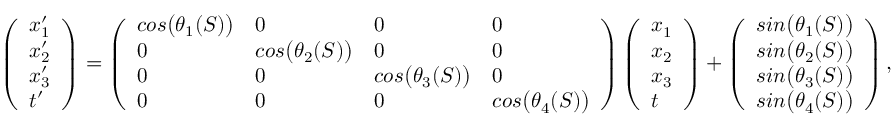<formula> <loc_0><loc_0><loc_500><loc_500>\begin{array} { r } { \left ( \begin{array} { l } { x _ { 1 } ^ { \prime } } \\ { x _ { 2 } ^ { \prime } } \\ { x _ { 3 } ^ { \prime } } \\ { t ^ { \prime } } \end{array} \right ) = \left ( \begin{array} { l l l l } { \cos \left ( \theta _ { 1 } ( S ) \right ) } & { 0 } & { 0 } & { 0 } \\ { 0 } & { \cos \left ( \theta _ { 2 } ( S ) \right ) } & { 0 } & { 0 } \\ { 0 } & { 0 } & { \cos \left ( \theta _ { 3 } ( S ) \right ) } & { 0 } \\ { 0 } & { 0 } & { 0 } & { \cos \left ( \theta _ { 4 } ( S ) \right ) } \end{array} \right ) \left ( \begin{array} { l } { x _ { 1 } } \\ { x _ { 2 } } \\ { x _ { 3 } } \\ { t } \end{array} \right ) + \left ( \begin{array} { l } { \sin \left ( \theta _ { 1 } ( S ) \right ) } \\ { \sin \left ( \theta _ { 2 } ( S ) \right ) } \\ { \sin \left ( \theta _ { 3 } ( S ) \right ) } \\ { \sin \left ( \theta _ { 4 } ( S ) \right ) } \end{array} \right ) , } \end{array}</formula> 